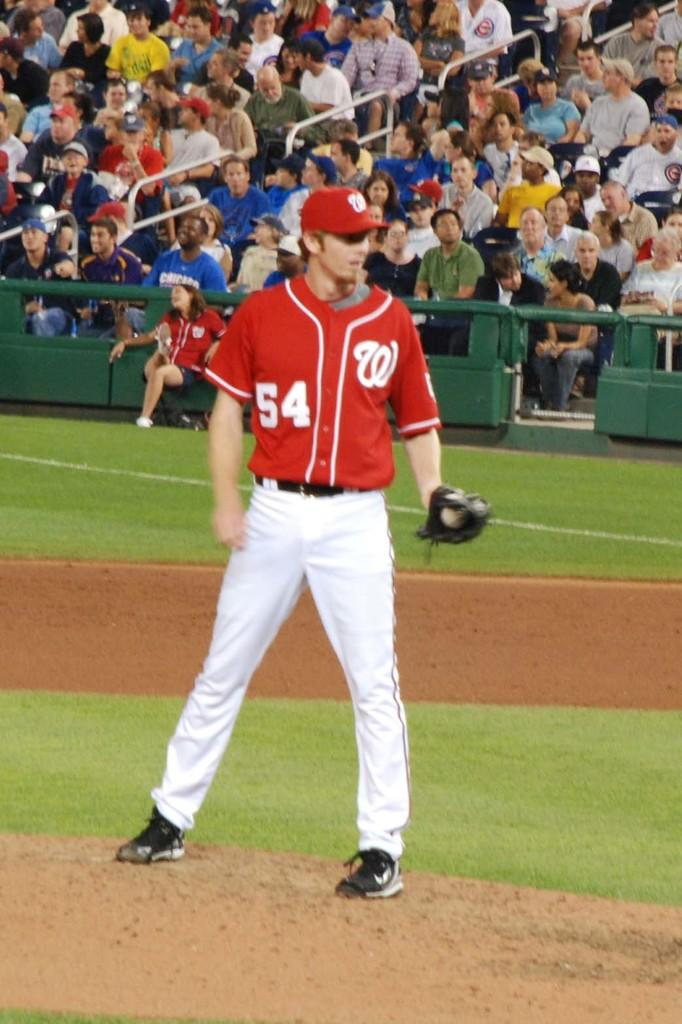<image>
Present a compact description of the photo's key features. A man in a baseball uniform has the number 54 on the front. 